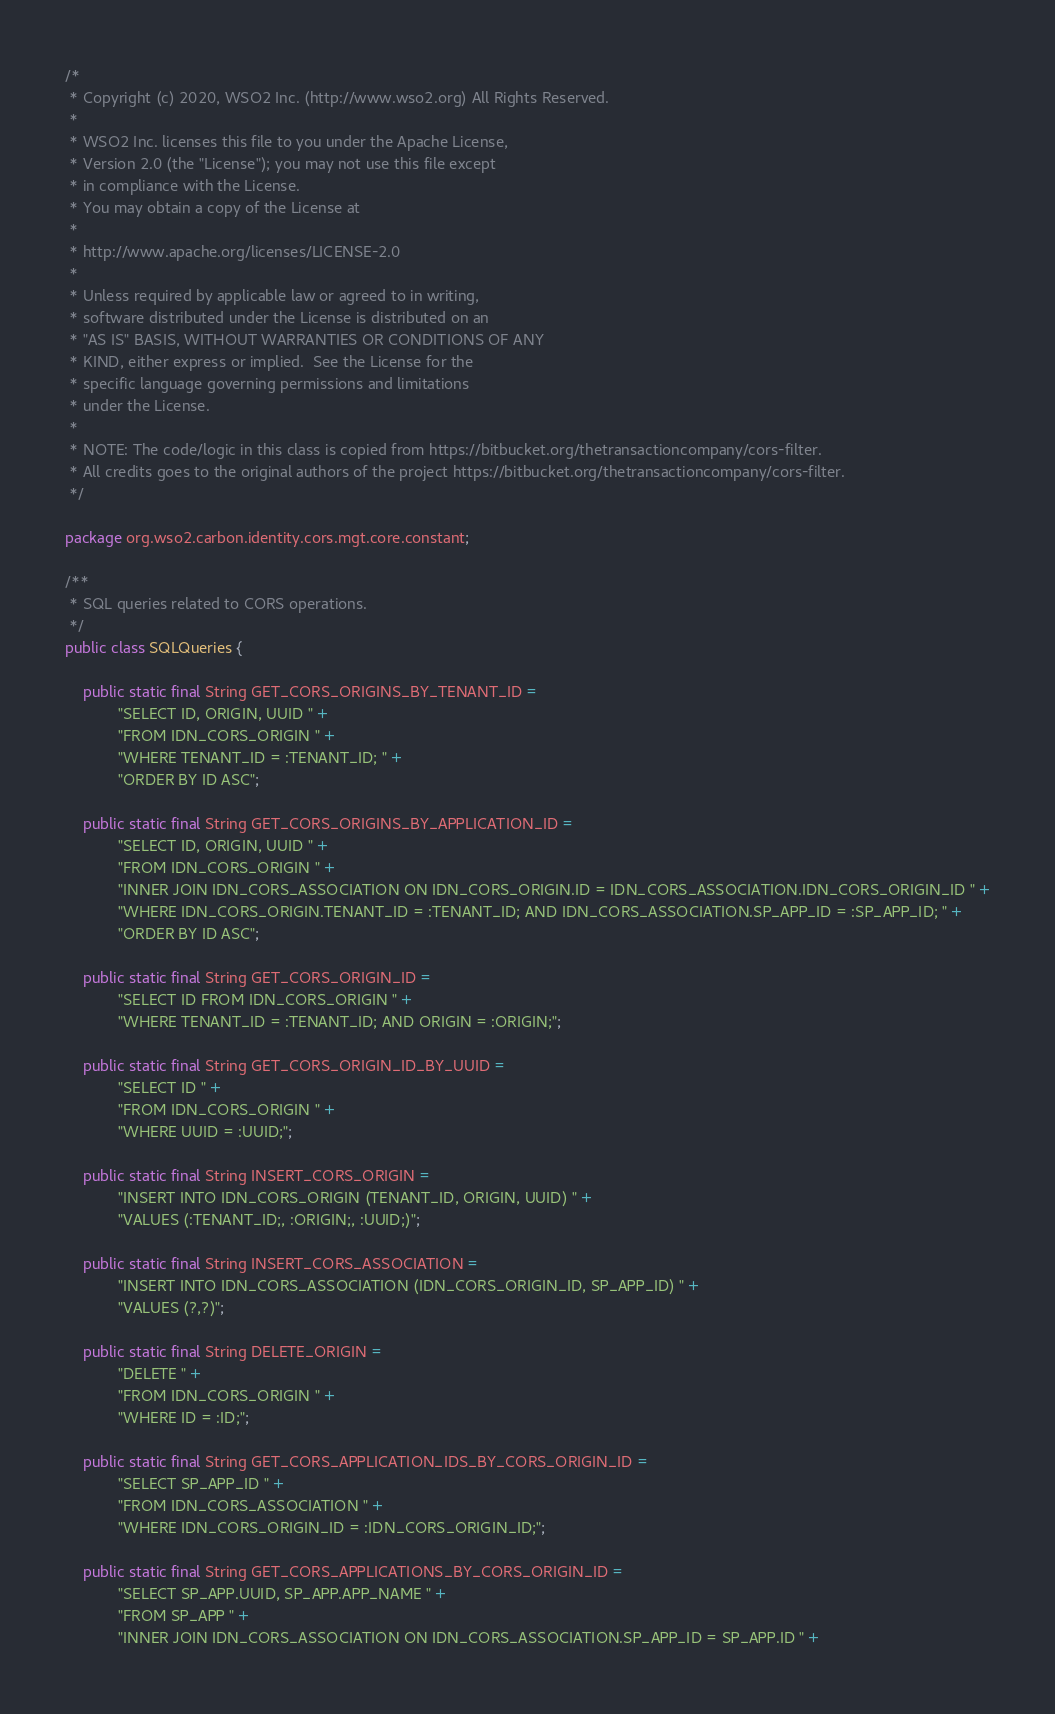<code> <loc_0><loc_0><loc_500><loc_500><_Java_>/*
 * Copyright (c) 2020, WSO2 Inc. (http://www.wso2.org) All Rights Reserved.
 *
 * WSO2 Inc. licenses this file to you under the Apache License,
 * Version 2.0 (the "License"); you may not use this file except
 * in compliance with the License.
 * You may obtain a copy of the License at
 *
 * http://www.apache.org/licenses/LICENSE-2.0
 *
 * Unless required by applicable law or agreed to in writing,
 * software distributed under the License is distributed on an
 * "AS IS" BASIS, WITHOUT WARRANTIES OR CONDITIONS OF ANY
 * KIND, either express or implied.  See the License for the
 * specific language governing permissions and limitations
 * under the License.
 *
 * NOTE: The code/logic in this class is copied from https://bitbucket.org/thetransactioncompany/cors-filter.
 * All credits goes to the original authors of the project https://bitbucket.org/thetransactioncompany/cors-filter.
 */

package org.wso2.carbon.identity.cors.mgt.core.constant;

/**
 * SQL queries related to CORS operations.
 */
public class SQLQueries {

    public static final String GET_CORS_ORIGINS_BY_TENANT_ID =
            "SELECT ID, ORIGIN, UUID " +
            "FROM IDN_CORS_ORIGIN " +
            "WHERE TENANT_ID = :TENANT_ID; " +
            "ORDER BY ID ASC";

    public static final String GET_CORS_ORIGINS_BY_APPLICATION_ID =
            "SELECT ID, ORIGIN, UUID " +
            "FROM IDN_CORS_ORIGIN " +
            "INNER JOIN IDN_CORS_ASSOCIATION ON IDN_CORS_ORIGIN.ID = IDN_CORS_ASSOCIATION.IDN_CORS_ORIGIN_ID " +
            "WHERE IDN_CORS_ORIGIN.TENANT_ID = :TENANT_ID; AND IDN_CORS_ASSOCIATION.SP_APP_ID = :SP_APP_ID; " +
            "ORDER BY ID ASC";

    public static final String GET_CORS_ORIGIN_ID =
            "SELECT ID FROM IDN_CORS_ORIGIN " +
            "WHERE TENANT_ID = :TENANT_ID; AND ORIGIN = :ORIGIN;";

    public static final String GET_CORS_ORIGIN_ID_BY_UUID =
            "SELECT ID " +
            "FROM IDN_CORS_ORIGIN " +
            "WHERE UUID = :UUID;";

    public static final String INSERT_CORS_ORIGIN =
            "INSERT INTO IDN_CORS_ORIGIN (TENANT_ID, ORIGIN, UUID) " +
            "VALUES (:TENANT_ID;, :ORIGIN;, :UUID;)";

    public static final String INSERT_CORS_ASSOCIATION =
            "INSERT INTO IDN_CORS_ASSOCIATION (IDN_CORS_ORIGIN_ID, SP_APP_ID) " +
            "VALUES (?,?)";

    public static final String DELETE_ORIGIN =
            "DELETE " +
            "FROM IDN_CORS_ORIGIN " +
            "WHERE ID = :ID;";

    public static final String GET_CORS_APPLICATION_IDS_BY_CORS_ORIGIN_ID =
            "SELECT SP_APP_ID " +
            "FROM IDN_CORS_ASSOCIATION " +
            "WHERE IDN_CORS_ORIGIN_ID = :IDN_CORS_ORIGIN_ID;";

    public static final String GET_CORS_APPLICATIONS_BY_CORS_ORIGIN_ID =
            "SELECT SP_APP.UUID, SP_APP.APP_NAME " +
            "FROM SP_APP " +
            "INNER JOIN IDN_CORS_ASSOCIATION ON IDN_CORS_ASSOCIATION.SP_APP_ID = SP_APP.ID " +</code> 